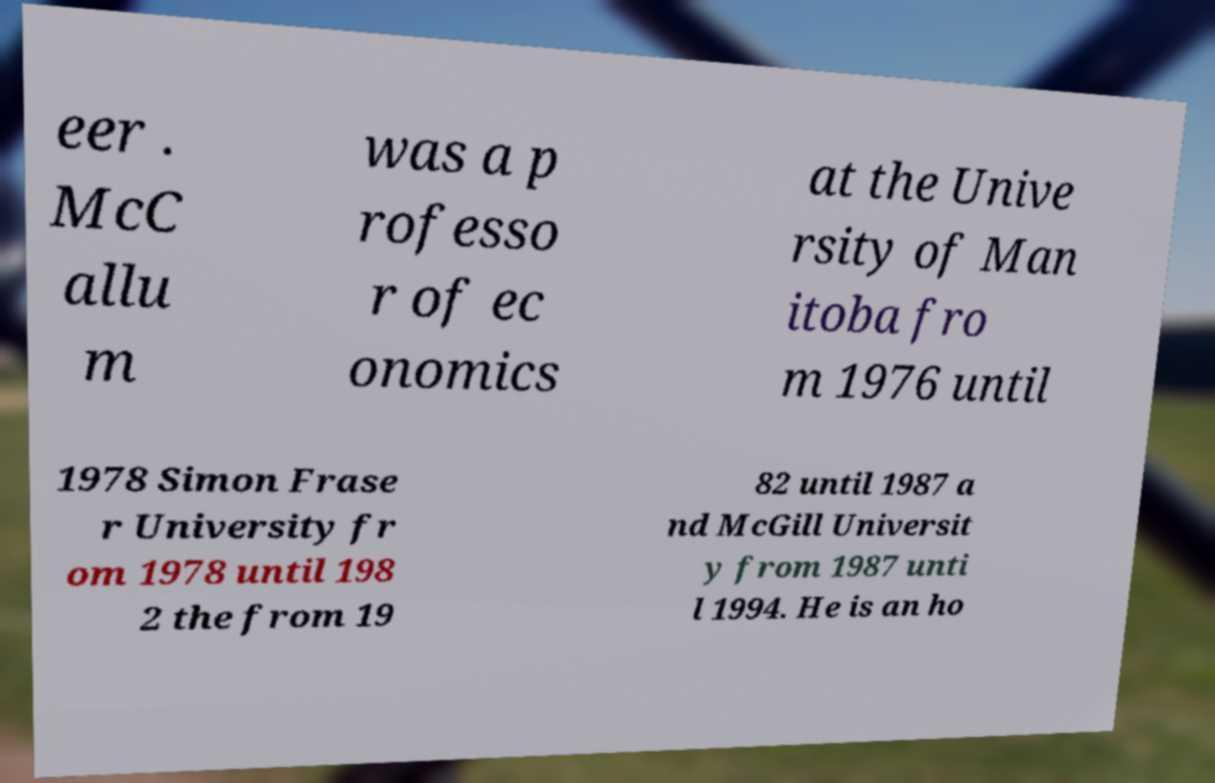Can you accurately transcribe the text from the provided image for me? eer . McC allu m was a p rofesso r of ec onomics at the Unive rsity of Man itoba fro m 1976 until 1978 Simon Frase r University fr om 1978 until 198 2 the from 19 82 until 1987 a nd McGill Universit y from 1987 unti l 1994. He is an ho 